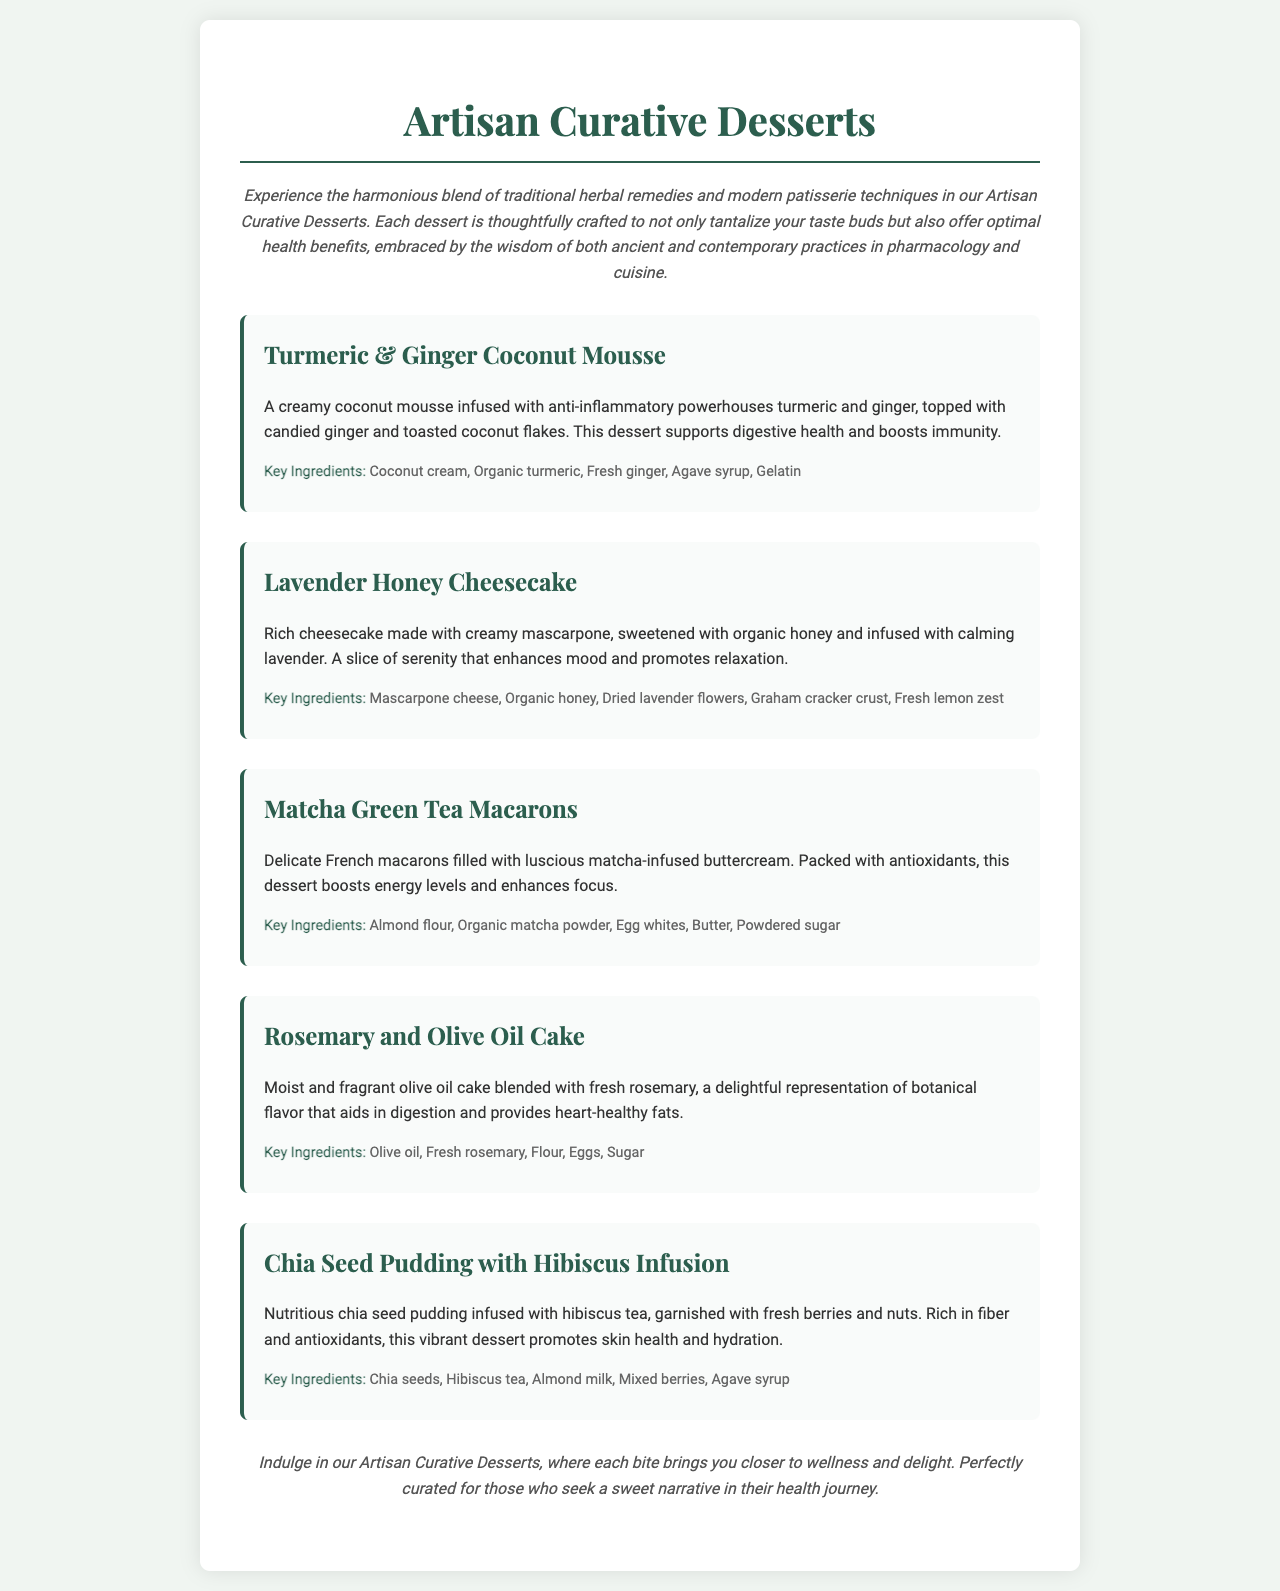What is the name of the first dessert? The first dessert listed in the menu is the "Turmeric & Ginger Coconut Mousse."
Answer: Turmeric & Ginger Coconut Mousse Which herbal ingredient is used in the Lavender Honey Cheesecake? The Lavender Honey Cheesecake is infused with calming lavender.
Answer: Lavender How many key ingredients are mentioned in the Matcha Green Tea Macarons? The key ingredients listed for the Matcha Green Tea Macarons are five: almond flour, organic matcha powder, egg whites, butter, and powdered sugar.
Answer: Five What health benefit does the Chia Seed Pudding with Hibiscus Infusion promote? The Chia Seed Pudding promotes skin health and hydration.
Answer: Skin health and hydration What type of cake is featured in the menu? The menu includes a "Rosemary and Olive Oil Cake."
Answer: Rosemary and Olive Oil Cake Which dessert is described as rich and calming? The dessert described as rich and calming is the Lavender Honey Cheesecake.
Answer: Lavender Honey Cheesecake How is the Turmeric & Ginger Coconut Mousse primarily characterized? It is characterized as a creamy coconut mousse infused with anti-inflammatory powerhouses turmeric and ginger.
Answer: Creamy coconut mousse What sweetener is used in the desserts? The desserts use agave syrup and organic honey as sweeteners.
Answer: Agave syrup and organic honey 